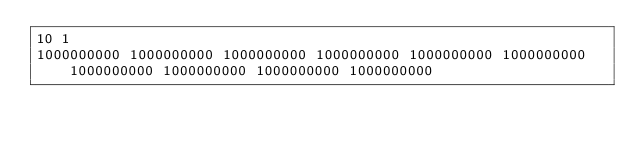Convert code to text. <code><loc_0><loc_0><loc_500><loc_500><_Java_>10 1
1000000000 1000000000 1000000000 1000000000 1000000000 1000000000 1000000000 1000000000 1000000000 1000000000</code> 